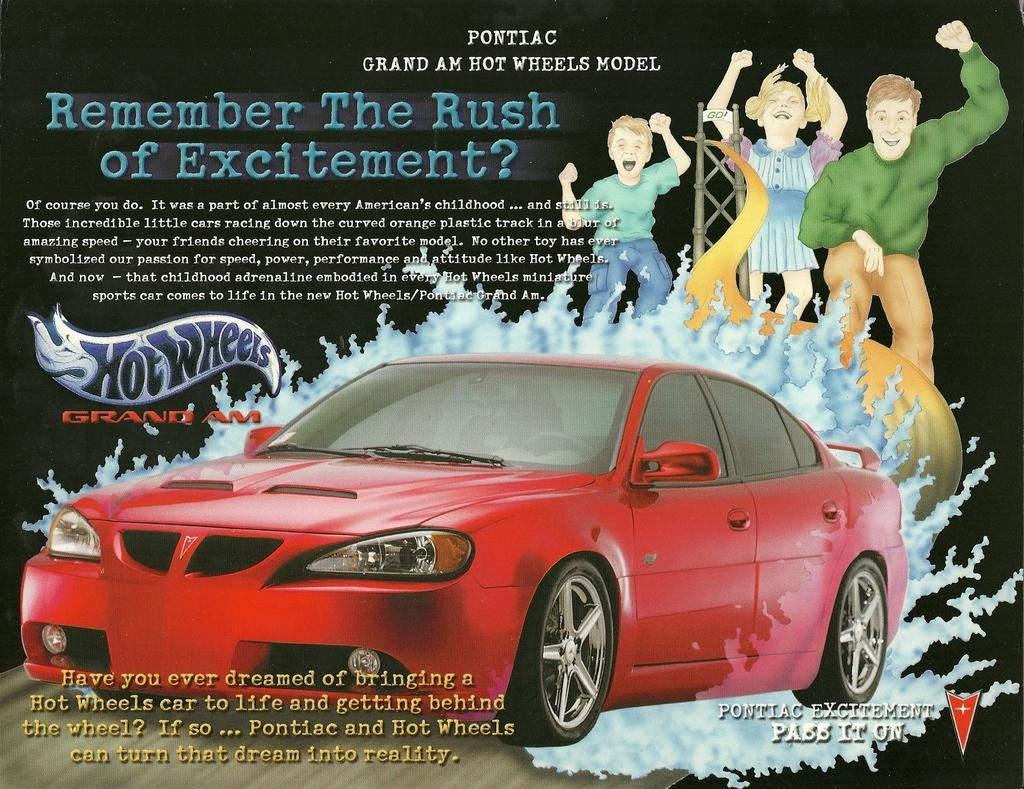What is featured on the poster in the image? There is a poster in the image that contains a red color car. What else can be seen on the poster besides the car? There is text on the poster and cartoon images of persons. What type of pain is the person experiencing in the image? There is no person experiencing pain in the image, as it only features a poster with a red car, text, and cartoon images of persons. 